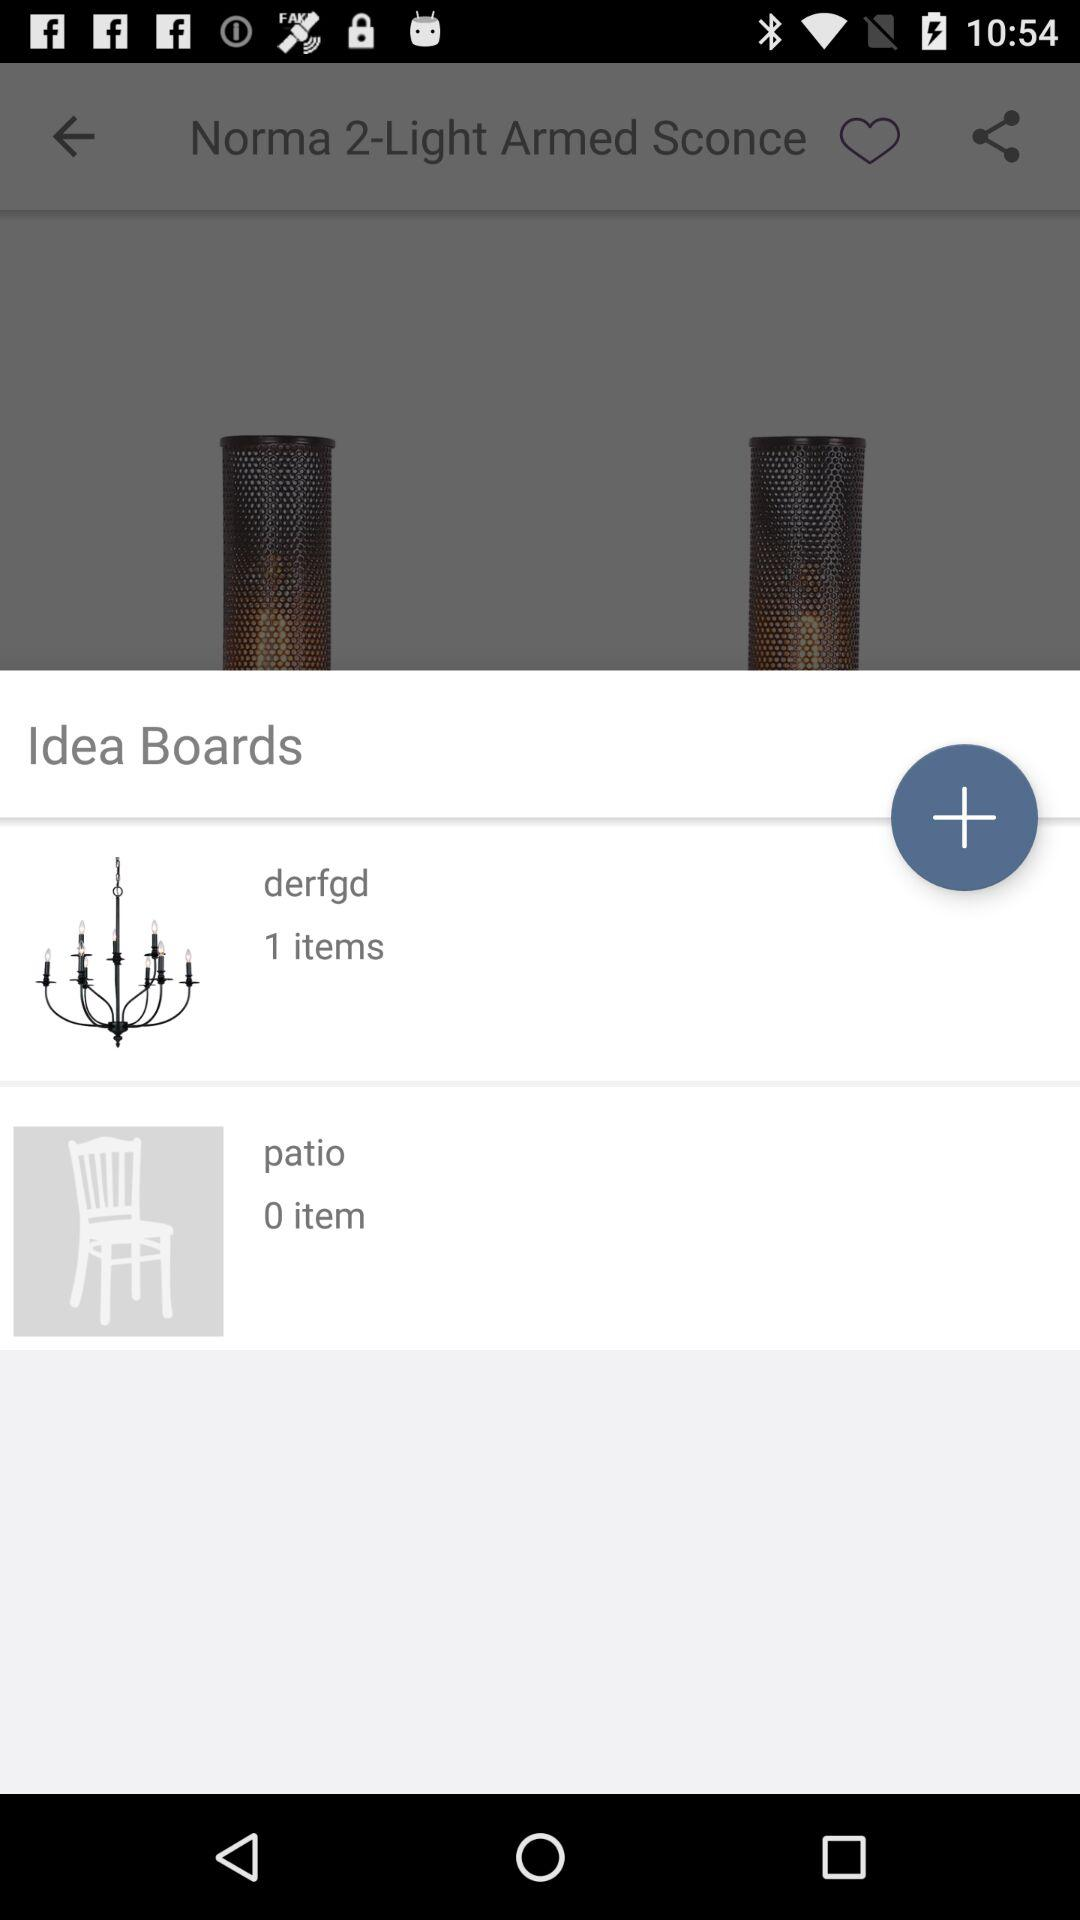This can be shared with which applications?
When the provided information is insufficient, respond with <no answer>. <no answer> 